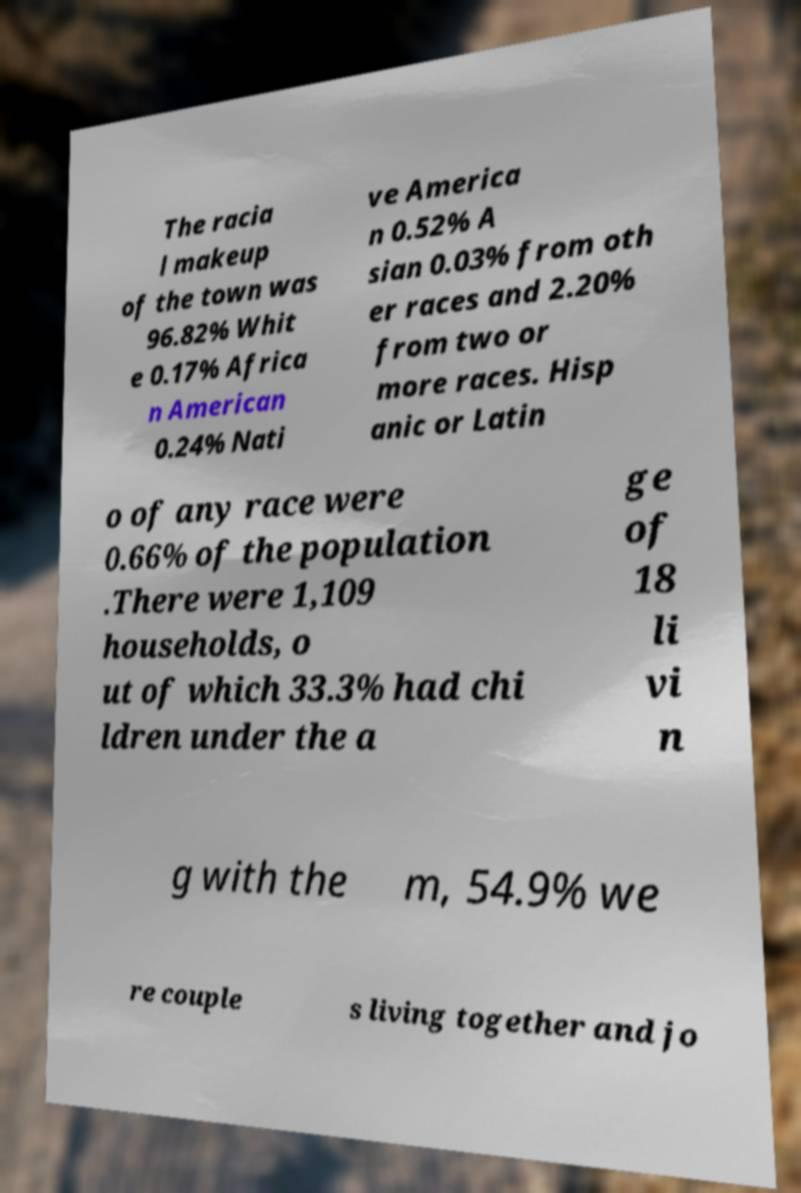Please identify and transcribe the text found in this image. The racia l makeup of the town was 96.82% Whit e 0.17% Africa n American 0.24% Nati ve America n 0.52% A sian 0.03% from oth er races and 2.20% from two or more races. Hisp anic or Latin o of any race were 0.66% of the population .There were 1,109 households, o ut of which 33.3% had chi ldren under the a ge of 18 li vi n g with the m, 54.9% we re couple s living together and jo 